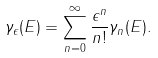Convert formula to latex. <formula><loc_0><loc_0><loc_500><loc_500>\gamma _ { \epsilon } ( E ) = \sum _ { n = 0 } ^ { \infty } \frac { \epsilon ^ { n } } { n ! } \gamma _ { n } ( E ) .</formula> 